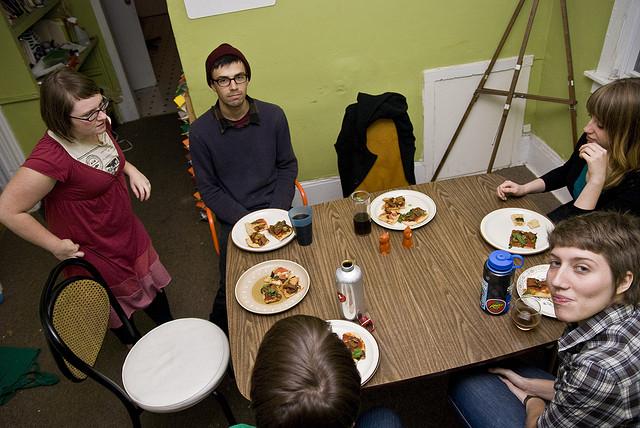Is everyone looking at the camera?
Give a very brief answer. No. How many plates are on the table?
Keep it brief. 6. What color is the woman's dress that's standing?
Give a very brief answer. Red. 